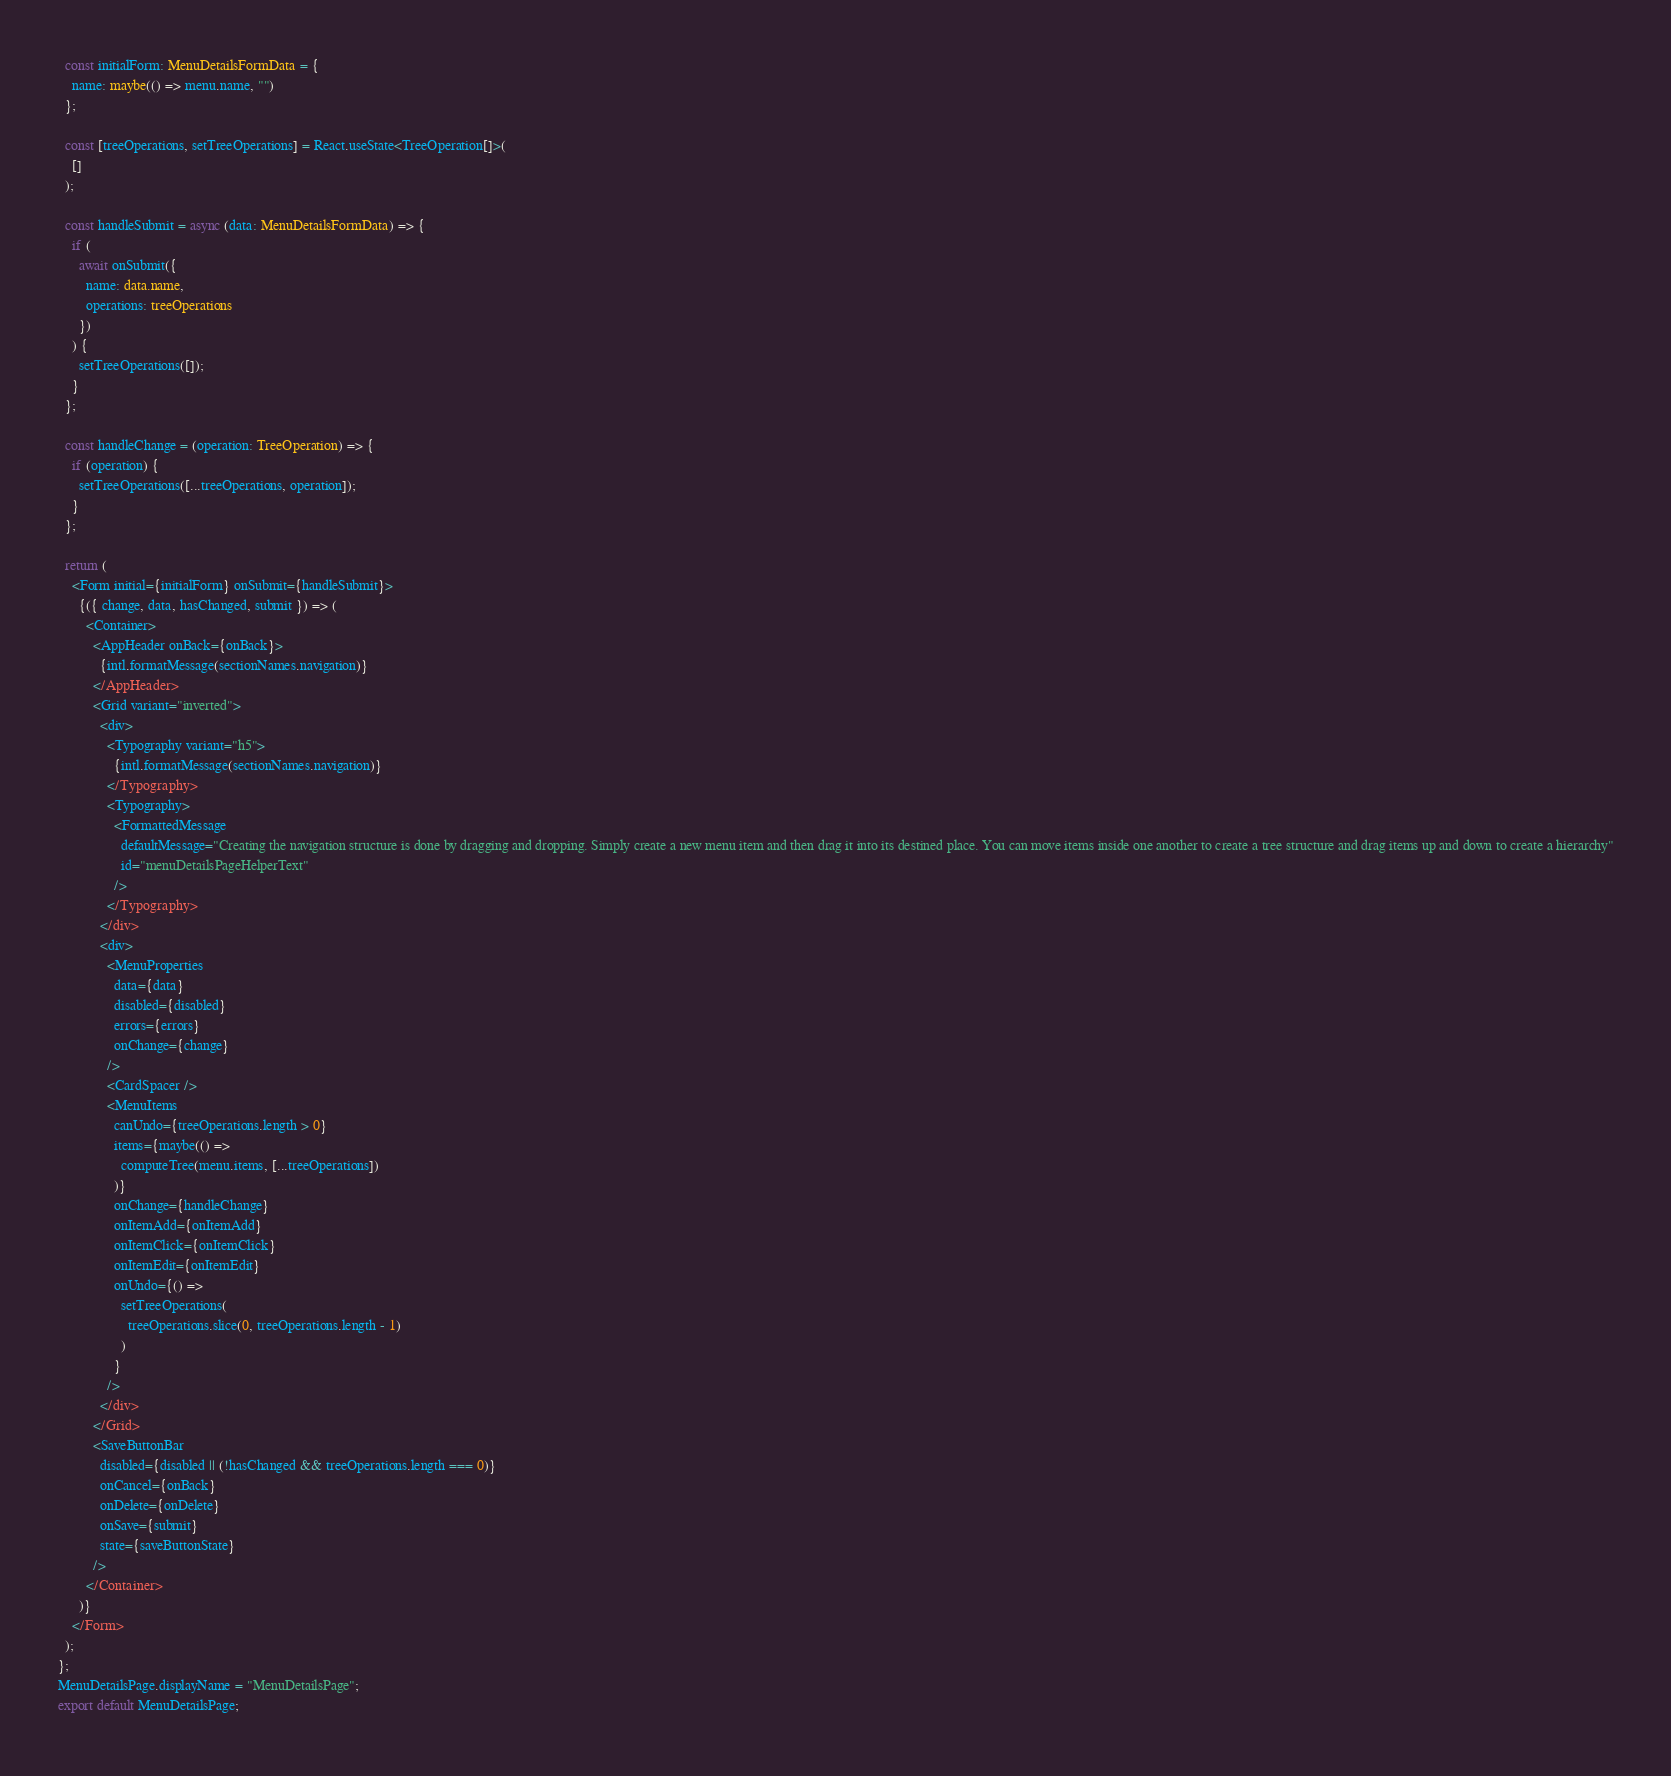<code> <loc_0><loc_0><loc_500><loc_500><_TypeScript_>  const initialForm: MenuDetailsFormData = {
    name: maybe(() => menu.name, "")
  };

  const [treeOperations, setTreeOperations] = React.useState<TreeOperation[]>(
    []
  );

  const handleSubmit = async (data: MenuDetailsFormData) => {
    if (
      await onSubmit({
        name: data.name,
        operations: treeOperations
      })
    ) {
      setTreeOperations([]);
    }
  };

  const handleChange = (operation: TreeOperation) => {
    if (operation) {
      setTreeOperations([...treeOperations, operation]);
    }
  };

  return (
    <Form initial={initialForm} onSubmit={handleSubmit}>
      {({ change, data, hasChanged, submit }) => (
        <Container>
          <AppHeader onBack={onBack}>
            {intl.formatMessage(sectionNames.navigation)}
          </AppHeader>
          <Grid variant="inverted">
            <div>
              <Typography variant="h5">
                {intl.formatMessage(sectionNames.navigation)}
              </Typography>
              <Typography>
                <FormattedMessage
                  defaultMessage="Creating the navigation structure is done by dragging and dropping. Simply create a new menu item and then drag it into its destined place. You can move items inside one another to create a tree structure and drag items up and down to create a hierarchy"
                  id="menuDetailsPageHelperText"
                />
              </Typography>
            </div>
            <div>
              <MenuProperties
                data={data}
                disabled={disabled}
                errors={errors}
                onChange={change}
              />
              <CardSpacer />
              <MenuItems
                canUndo={treeOperations.length > 0}
                items={maybe(() =>
                  computeTree(menu.items, [...treeOperations])
                )}
                onChange={handleChange}
                onItemAdd={onItemAdd}
                onItemClick={onItemClick}
                onItemEdit={onItemEdit}
                onUndo={() =>
                  setTreeOperations(
                    treeOperations.slice(0, treeOperations.length - 1)
                  )
                }
              />
            </div>
          </Grid>
          <SaveButtonBar
            disabled={disabled || (!hasChanged && treeOperations.length === 0)}
            onCancel={onBack}
            onDelete={onDelete}
            onSave={submit}
            state={saveButtonState}
          />
        </Container>
      )}
    </Form>
  );
};
MenuDetailsPage.displayName = "MenuDetailsPage";
export default MenuDetailsPage;
</code> 